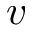Convert formula to latex. <formula><loc_0><loc_0><loc_500><loc_500>v</formula> 